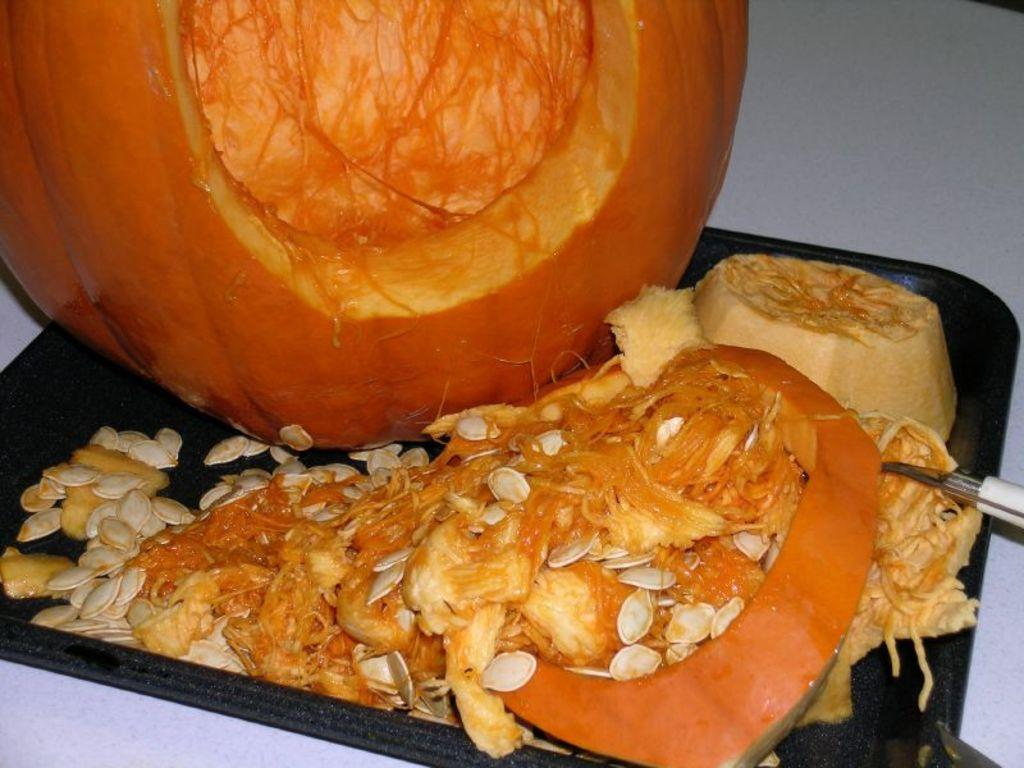What is placed on the tray in the image? There is a pumpkin placed on a tray in the image. What tool is visible on the right side of the image? There is a peeler on the right side of the image. What piece of furniture is at the bottom of the image? There is a table at the bottom of the image. What type of ticket is visible on the table in the image? There is no ticket present in the image; only a pumpkin, a peeler, and a table are visible. 